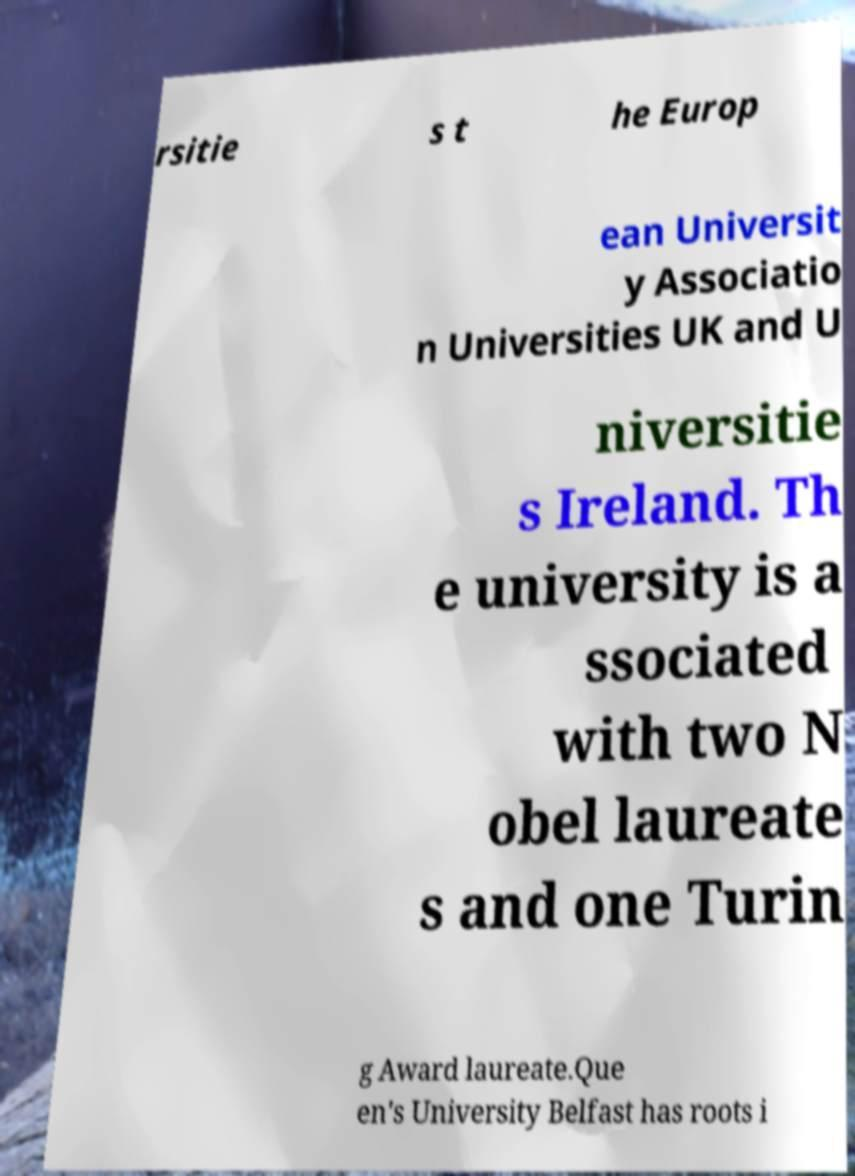There's text embedded in this image that I need extracted. Can you transcribe it verbatim? rsitie s t he Europ ean Universit y Associatio n Universities UK and U niversitie s Ireland. Th e university is a ssociated with two N obel laureate s and one Turin g Award laureate.Que en's University Belfast has roots i 